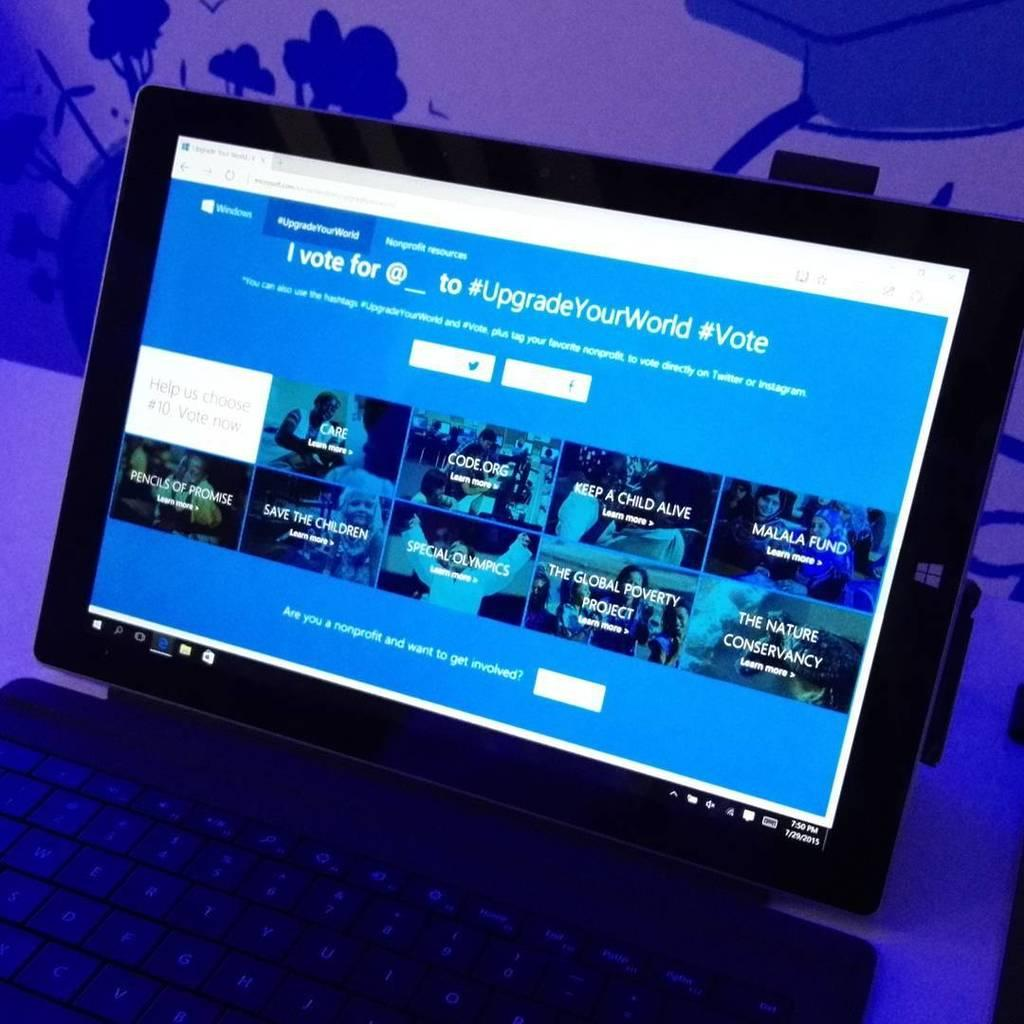<image>
Write a terse but informative summary of the picture. A Windows computer shows a screen that reads "#upgradeyourworld" 